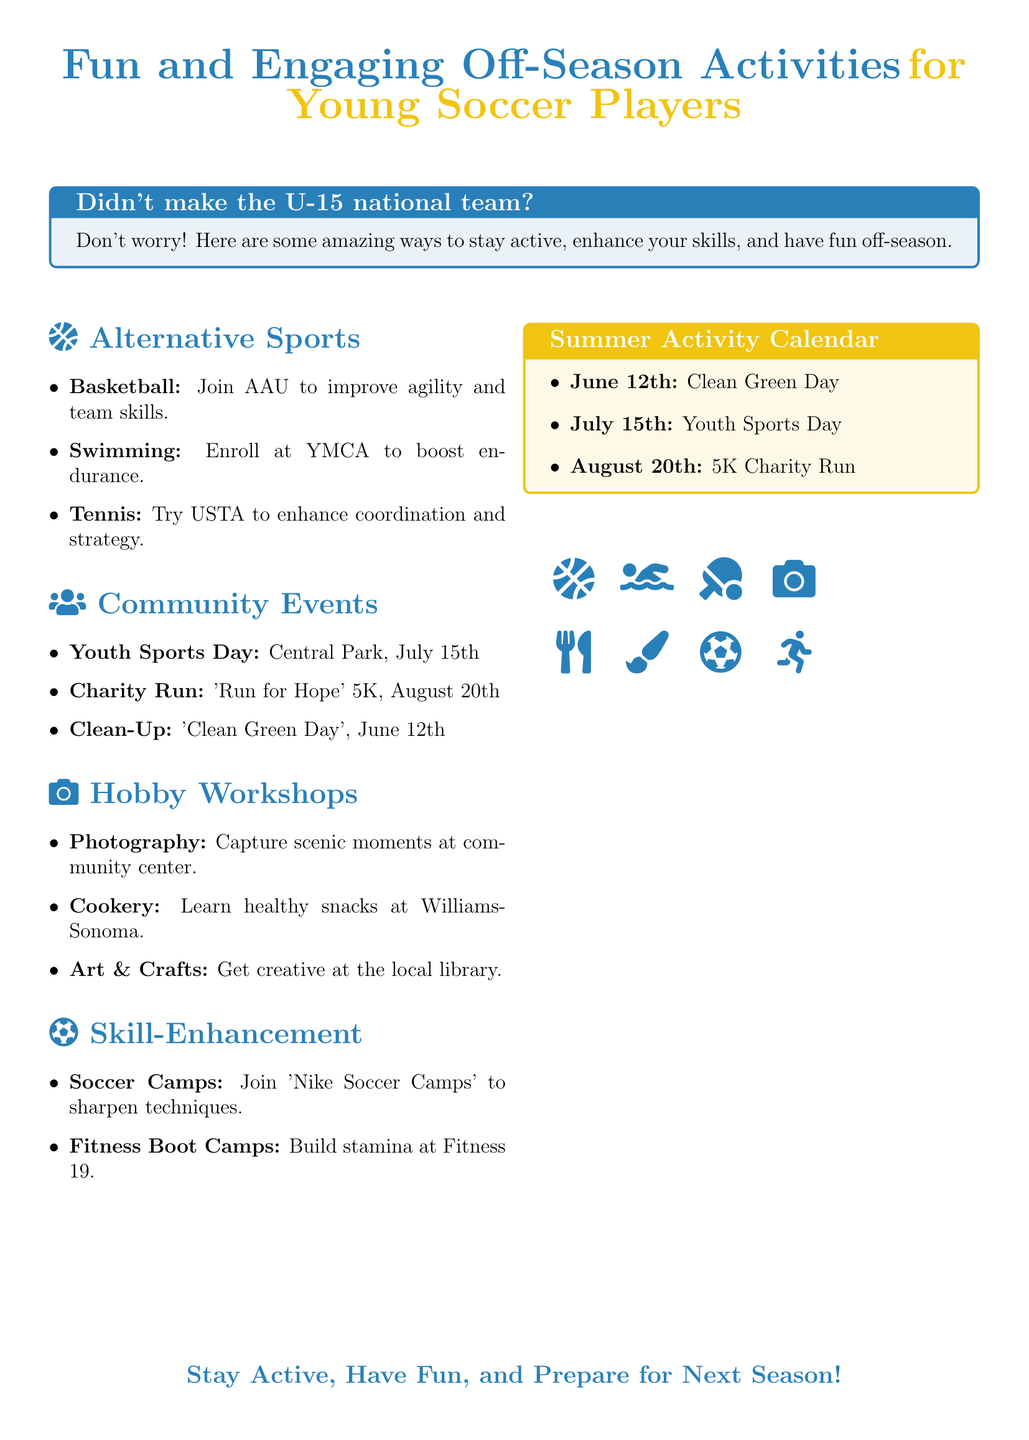What is the date of the Clean-Up event? The date of the Clean-Up event is listed in the Community Events section.
Answer: June 12th What sport is suggested for improving agility? Improving agility can be achieved by joining Basketball, as mentioned in the Alternative Sports section.
Answer: Basketball How many alternative sports are mentioned? The number of alternative sports can be counted from the Alternative Sports section.
Answer: Three What is the title of the skill-enhancement program? The title of the skill-enhancement program is referenced in the Skill-Enhancement section.
Answer: Nike Soccer Camps Where is the Youth Sports Day taking place? The location of the Youth Sports Day is specified in the Community Events section.
Answer: Central Park Which workshop teaches healthy snacks? The workshop that teaches healthy snacks is mentioned in the Hobby Workshops section.
Answer: Cookery What type of camp is offered at Fitness 19? The type of camp offered at Fitness 19 can be identified in the Skill-Enhancement section.
Answer: Fitness Boot Camps What color is used for the titles in the document? The color used for the titles can be found throughout the document.
Answer: Teen blue 